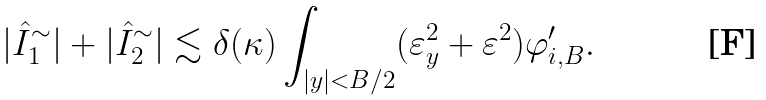<formula> <loc_0><loc_0><loc_500><loc_500>| \hat { I } _ { 1 } ^ { \sim } | + | \hat { I } _ { 2 } ^ { \sim } | \lesssim \delta ( \kappa ) \int _ { | y | < B / 2 } ( \varepsilon _ { y } ^ { 2 } + \varepsilon ^ { 2 } ) \varphi _ { i , B } ^ { \prime } .</formula> 